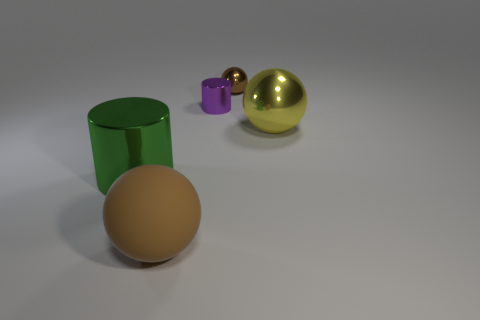Subtract all large matte spheres. How many spheres are left? 2 Subtract all yellow spheres. How many cyan cylinders are left? 0 Subtract all small purple metallic blocks. Subtract all large objects. How many objects are left? 2 Add 3 tiny brown metallic things. How many tiny brown metallic things are left? 4 Add 2 large shiny objects. How many large shiny objects exist? 4 Add 2 rubber balls. How many objects exist? 7 Subtract all brown balls. How many balls are left? 1 Subtract 0 gray blocks. How many objects are left? 5 Subtract all cylinders. How many objects are left? 3 Subtract 3 balls. How many balls are left? 0 